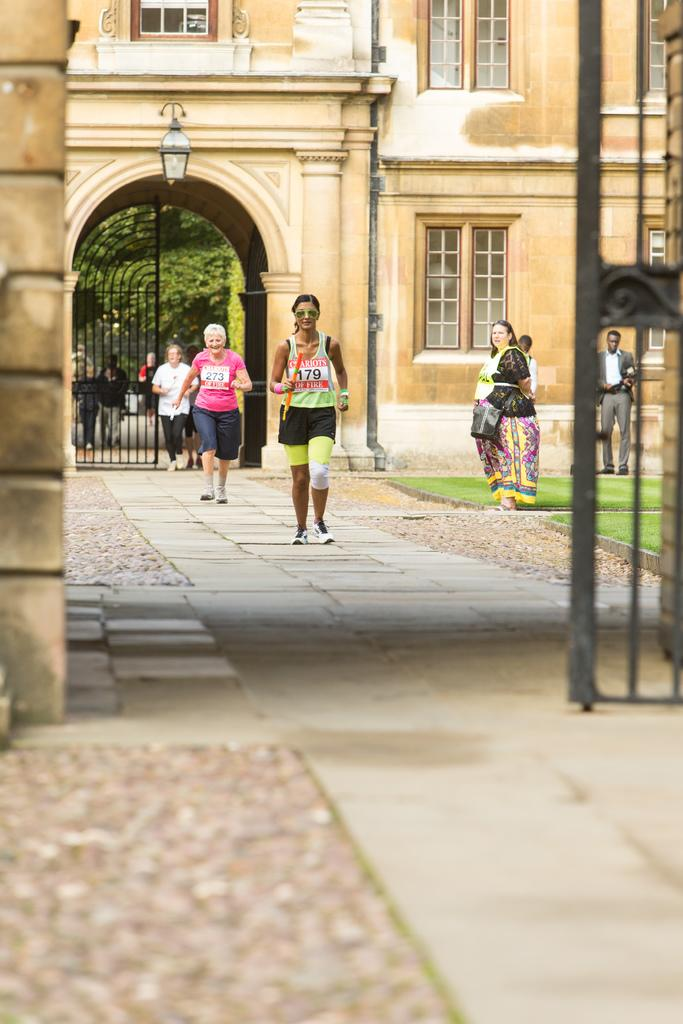What are the people in the image doing? The people in the image are walking in a path. What can be seen in the background of the image? There are buildings visible in the image. What type of vegetation is present in the image? There are trees in the image, and there is also grass. Can you tell me how many basketballs are being coached by the spiders in the image? There are no spiders, basketballs, or coaches present in the image. 